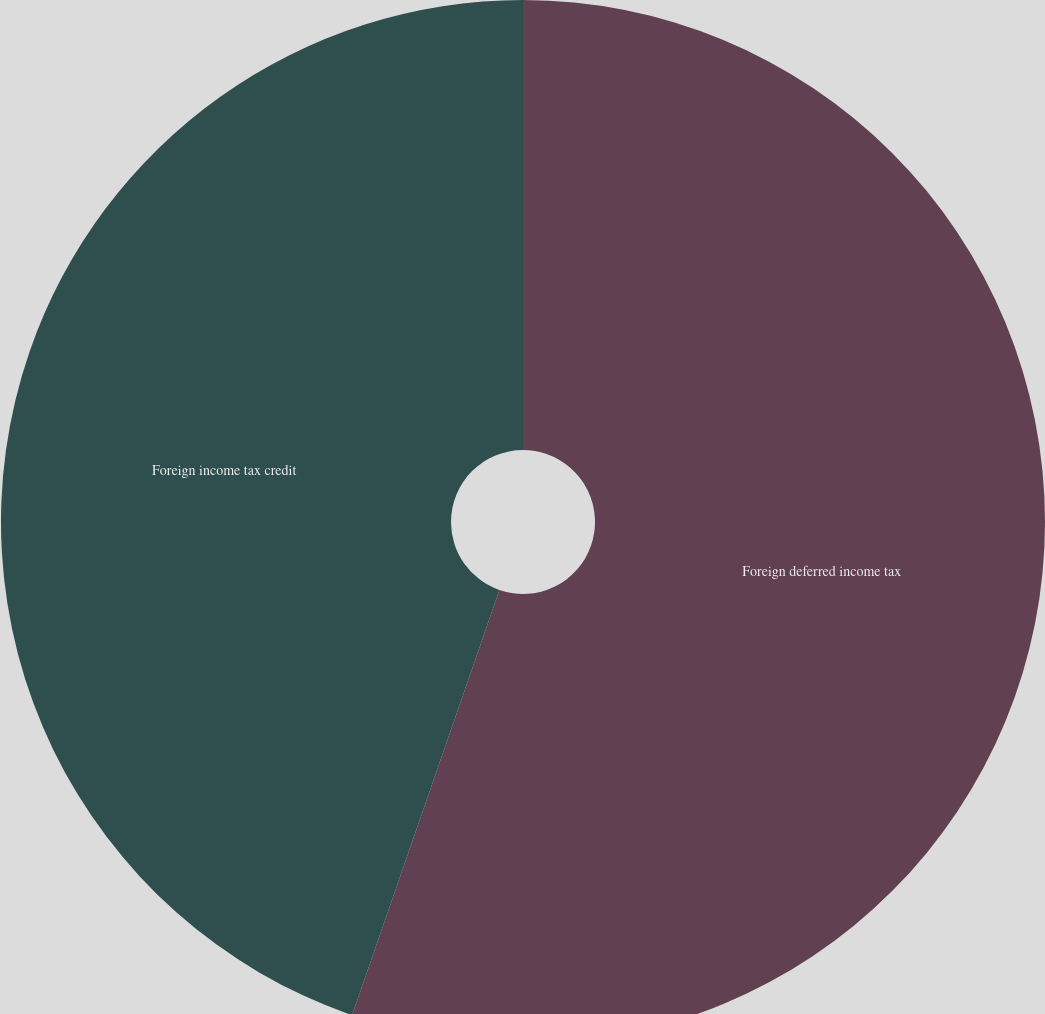Convert chart to OTSL. <chart><loc_0><loc_0><loc_500><loc_500><pie_chart><fcel>Foreign deferred income tax<fcel>Foreign income tax credit<nl><fcel>55.31%<fcel>44.69%<nl></chart> 